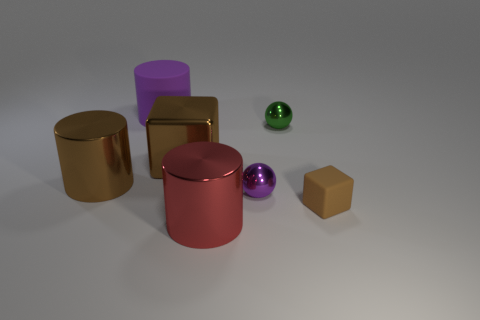Add 3 small spheres. How many objects exist? 10 Subtract all cylinders. How many objects are left? 4 Subtract all large purple metal objects. Subtract all tiny balls. How many objects are left? 5 Add 6 brown metallic objects. How many brown metallic objects are left? 8 Add 4 big red cylinders. How many big red cylinders exist? 5 Subtract 0 cyan spheres. How many objects are left? 7 